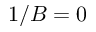<formula> <loc_0><loc_0><loc_500><loc_500>1 / B = 0</formula> 